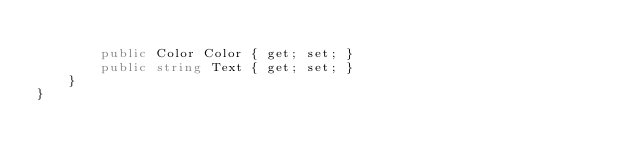<code> <loc_0><loc_0><loc_500><loc_500><_C#_>
        public Color Color { get; set; }
        public string Text { get; set; }
    }
}</code> 